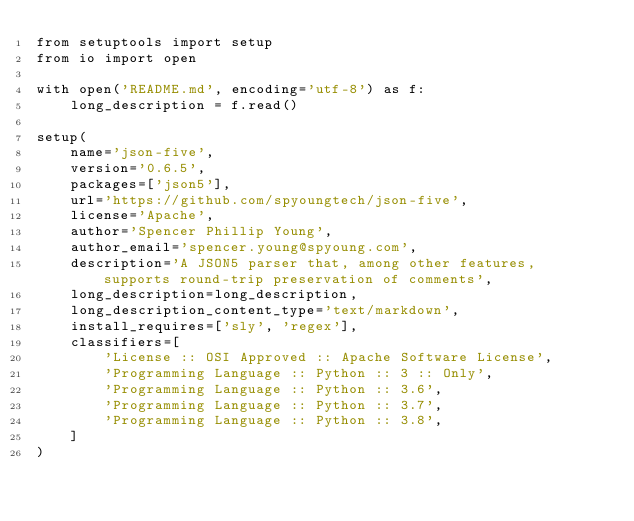<code> <loc_0><loc_0><loc_500><loc_500><_Python_>from setuptools import setup
from io import open

with open('README.md', encoding='utf-8') as f:
    long_description = f.read()

setup(
    name='json-five',
    version='0.6.5',
    packages=['json5'],
    url='https://github.com/spyoungtech/json-five',
    license='Apache',
    author='Spencer Phillip Young',
    author_email='spencer.young@spyoung.com',
    description='A JSON5 parser that, among other features, supports round-trip preservation of comments',
    long_description=long_description,
    long_description_content_type='text/markdown',
    install_requires=['sly', 'regex'],
    classifiers=[
        'License :: OSI Approved :: Apache Software License',
        'Programming Language :: Python :: 3 :: Only',
        'Programming Language :: Python :: 3.6',
        'Programming Language :: Python :: 3.7',
        'Programming Language :: Python :: 3.8',
    ]
)
</code> 